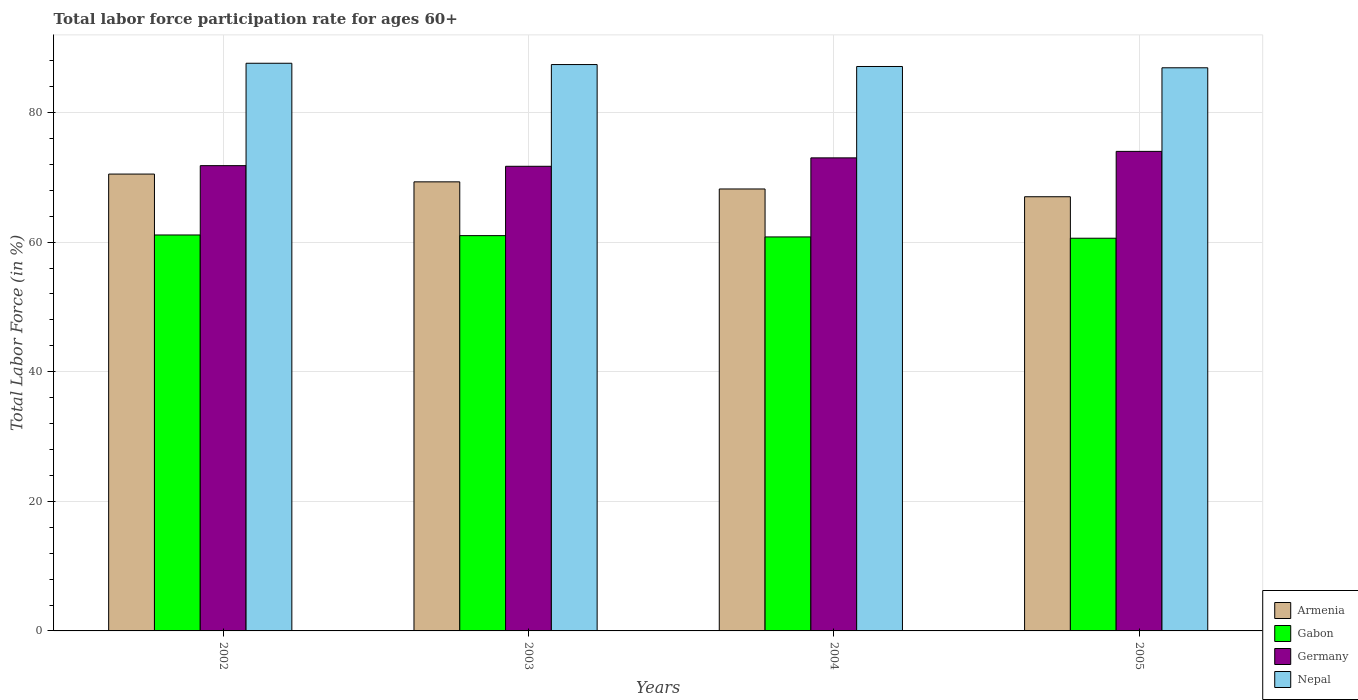Are the number of bars on each tick of the X-axis equal?
Keep it short and to the point. Yes. How many bars are there on the 1st tick from the left?
Keep it short and to the point. 4. How many bars are there on the 2nd tick from the right?
Keep it short and to the point. 4. What is the label of the 1st group of bars from the left?
Your answer should be very brief. 2002. In how many cases, is the number of bars for a given year not equal to the number of legend labels?
Ensure brevity in your answer.  0. What is the labor force participation rate in Gabon in 2004?
Offer a terse response. 60.8. Across all years, what is the maximum labor force participation rate in Gabon?
Your answer should be compact. 61.1. Across all years, what is the minimum labor force participation rate in Armenia?
Your answer should be compact. 67. In which year was the labor force participation rate in Germany maximum?
Give a very brief answer. 2005. What is the total labor force participation rate in Gabon in the graph?
Keep it short and to the point. 243.5. What is the difference between the labor force participation rate in Germany in 2003 and that in 2004?
Keep it short and to the point. -1.3. What is the difference between the labor force participation rate in Germany in 2002 and the labor force participation rate in Gabon in 2004?
Offer a very short reply. 11. What is the average labor force participation rate in Nepal per year?
Provide a short and direct response. 87.25. In the year 2002, what is the difference between the labor force participation rate in Gabon and labor force participation rate in Germany?
Offer a very short reply. -10.7. In how many years, is the labor force participation rate in Armenia greater than 80 %?
Offer a very short reply. 0. What is the ratio of the labor force participation rate in Gabon in 2004 to that in 2005?
Offer a terse response. 1. Is the labor force participation rate in Gabon in 2004 less than that in 2005?
Provide a short and direct response. No. What is the difference between the highest and the second highest labor force participation rate in Gabon?
Make the answer very short. 0.1. What is the difference between the highest and the lowest labor force participation rate in Germany?
Make the answer very short. 2.3. In how many years, is the labor force participation rate in Germany greater than the average labor force participation rate in Germany taken over all years?
Offer a terse response. 2. What does the 1st bar from the left in 2005 represents?
Offer a very short reply. Armenia. Is it the case that in every year, the sum of the labor force participation rate in Germany and labor force participation rate in Nepal is greater than the labor force participation rate in Armenia?
Your answer should be very brief. Yes. Are all the bars in the graph horizontal?
Keep it short and to the point. No. What is the difference between two consecutive major ticks on the Y-axis?
Give a very brief answer. 20. Are the values on the major ticks of Y-axis written in scientific E-notation?
Keep it short and to the point. No. Does the graph contain grids?
Keep it short and to the point. Yes. How many legend labels are there?
Provide a succinct answer. 4. What is the title of the graph?
Your answer should be very brief. Total labor force participation rate for ages 60+. What is the label or title of the X-axis?
Provide a short and direct response. Years. What is the Total Labor Force (in %) of Armenia in 2002?
Your answer should be compact. 70.5. What is the Total Labor Force (in %) of Gabon in 2002?
Your response must be concise. 61.1. What is the Total Labor Force (in %) in Germany in 2002?
Give a very brief answer. 71.8. What is the Total Labor Force (in %) in Nepal in 2002?
Provide a succinct answer. 87.6. What is the Total Labor Force (in %) in Armenia in 2003?
Give a very brief answer. 69.3. What is the Total Labor Force (in %) in Gabon in 2003?
Provide a succinct answer. 61. What is the Total Labor Force (in %) in Germany in 2003?
Make the answer very short. 71.7. What is the Total Labor Force (in %) of Nepal in 2003?
Provide a short and direct response. 87.4. What is the Total Labor Force (in %) in Armenia in 2004?
Provide a short and direct response. 68.2. What is the Total Labor Force (in %) of Gabon in 2004?
Your answer should be compact. 60.8. What is the Total Labor Force (in %) in Nepal in 2004?
Make the answer very short. 87.1. What is the Total Labor Force (in %) in Armenia in 2005?
Offer a very short reply. 67. What is the Total Labor Force (in %) of Gabon in 2005?
Keep it short and to the point. 60.6. What is the Total Labor Force (in %) of Nepal in 2005?
Your answer should be compact. 86.9. Across all years, what is the maximum Total Labor Force (in %) in Armenia?
Offer a very short reply. 70.5. Across all years, what is the maximum Total Labor Force (in %) of Gabon?
Make the answer very short. 61.1. Across all years, what is the maximum Total Labor Force (in %) in Germany?
Make the answer very short. 74. Across all years, what is the maximum Total Labor Force (in %) in Nepal?
Provide a succinct answer. 87.6. Across all years, what is the minimum Total Labor Force (in %) of Gabon?
Give a very brief answer. 60.6. Across all years, what is the minimum Total Labor Force (in %) of Germany?
Make the answer very short. 71.7. Across all years, what is the minimum Total Labor Force (in %) of Nepal?
Provide a succinct answer. 86.9. What is the total Total Labor Force (in %) in Armenia in the graph?
Provide a succinct answer. 275. What is the total Total Labor Force (in %) of Gabon in the graph?
Ensure brevity in your answer.  243.5. What is the total Total Labor Force (in %) of Germany in the graph?
Provide a short and direct response. 290.5. What is the total Total Labor Force (in %) in Nepal in the graph?
Provide a succinct answer. 349. What is the difference between the Total Labor Force (in %) of Gabon in 2002 and that in 2003?
Make the answer very short. 0.1. What is the difference between the Total Labor Force (in %) in Germany in 2002 and that in 2003?
Give a very brief answer. 0.1. What is the difference between the Total Labor Force (in %) of Nepal in 2002 and that in 2003?
Provide a short and direct response. 0.2. What is the difference between the Total Labor Force (in %) of Armenia in 2002 and that in 2004?
Provide a short and direct response. 2.3. What is the difference between the Total Labor Force (in %) of Gabon in 2002 and that in 2004?
Keep it short and to the point. 0.3. What is the difference between the Total Labor Force (in %) in Germany in 2002 and that in 2004?
Make the answer very short. -1.2. What is the difference between the Total Labor Force (in %) in Nepal in 2002 and that in 2004?
Your response must be concise. 0.5. What is the difference between the Total Labor Force (in %) of Armenia in 2002 and that in 2005?
Make the answer very short. 3.5. What is the difference between the Total Labor Force (in %) in Gabon in 2002 and that in 2005?
Provide a succinct answer. 0.5. What is the difference between the Total Labor Force (in %) of Germany in 2002 and that in 2005?
Make the answer very short. -2.2. What is the difference between the Total Labor Force (in %) of Nepal in 2002 and that in 2005?
Provide a succinct answer. 0.7. What is the difference between the Total Labor Force (in %) of Armenia in 2003 and that in 2004?
Make the answer very short. 1.1. What is the difference between the Total Labor Force (in %) of Germany in 2003 and that in 2004?
Your response must be concise. -1.3. What is the difference between the Total Labor Force (in %) in Gabon in 2003 and that in 2005?
Provide a succinct answer. 0.4. What is the difference between the Total Labor Force (in %) of Germany in 2003 and that in 2005?
Your response must be concise. -2.3. What is the difference between the Total Labor Force (in %) in Nepal in 2003 and that in 2005?
Ensure brevity in your answer.  0.5. What is the difference between the Total Labor Force (in %) in Nepal in 2004 and that in 2005?
Provide a succinct answer. 0.2. What is the difference between the Total Labor Force (in %) in Armenia in 2002 and the Total Labor Force (in %) in Nepal in 2003?
Your answer should be compact. -16.9. What is the difference between the Total Labor Force (in %) in Gabon in 2002 and the Total Labor Force (in %) in Germany in 2003?
Offer a terse response. -10.6. What is the difference between the Total Labor Force (in %) in Gabon in 2002 and the Total Labor Force (in %) in Nepal in 2003?
Provide a succinct answer. -26.3. What is the difference between the Total Labor Force (in %) in Germany in 2002 and the Total Labor Force (in %) in Nepal in 2003?
Ensure brevity in your answer.  -15.6. What is the difference between the Total Labor Force (in %) in Armenia in 2002 and the Total Labor Force (in %) in Germany in 2004?
Keep it short and to the point. -2.5. What is the difference between the Total Labor Force (in %) in Armenia in 2002 and the Total Labor Force (in %) in Nepal in 2004?
Make the answer very short. -16.6. What is the difference between the Total Labor Force (in %) of Germany in 2002 and the Total Labor Force (in %) of Nepal in 2004?
Give a very brief answer. -15.3. What is the difference between the Total Labor Force (in %) of Armenia in 2002 and the Total Labor Force (in %) of Gabon in 2005?
Keep it short and to the point. 9.9. What is the difference between the Total Labor Force (in %) of Armenia in 2002 and the Total Labor Force (in %) of Nepal in 2005?
Your answer should be compact. -16.4. What is the difference between the Total Labor Force (in %) of Gabon in 2002 and the Total Labor Force (in %) of Nepal in 2005?
Provide a succinct answer. -25.8. What is the difference between the Total Labor Force (in %) of Germany in 2002 and the Total Labor Force (in %) of Nepal in 2005?
Keep it short and to the point. -15.1. What is the difference between the Total Labor Force (in %) of Armenia in 2003 and the Total Labor Force (in %) of Germany in 2004?
Make the answer very short. -3.7. What is the difference between the Total Labor Force (in %) in Armenia in 2003 and the Total Labor Force (in %) in Nepal in 2004?
Your answer should be very brief. -17.8. What is the difference between the Total Labor Force (in %) of Gabon in 2003 and the Total Labor Force (in %) of Germany in 2004?
Make the answer very short. -12. What is the difference between the Total Labor Force (in %) in Gabon in 2003 and the Total Labor Force (in %) in Nepal in 2004?
Offer a very short reply. -26.1. What is the difference between the Total Labor Force (in %) of Germany in 2003 and the Total Labor Force (in %) of Nepal in 2004?
Your answer should be compact. -15.4. What is the difference between the Total Labor Force (in %) of Armenia in 2003 and the Total Labor Force (in %) of Nepal in 2005?
Keep it short and to the point. -17.6. What is the difference between the Total Labor Force (in %) in Gabon in 2003 and the Total Labor Force (in %) in Nepal in 2005?
Make the answer very short. -25.9. What is the difference between the Total Labor Force (in %) of Germany in 2003 and the Total Labor Force (in %) of Nepal in 2005?
Your answer should be compact. -15.2. What is the difference between the Total Labor Force (in %) of Armenia in 2004 and the Total Labor Force (in %) of Germany in 2005?
Ensure brevity in your answer.  -5.8. What is the difference between the Total Labor Force (in %) of Armenia in 2004 and the Total Labor Force (in %) of Nepal in 2005?
Your answer should be compact. -18.7. What is the difference between the Total Labor Force (in %) of Gabon in 2004 and the Total Labor Force (in %) of Nepal in 2005?
Offer a very short reply. -26.1. What is the difference between the Total Labor Force (in %) in Germany in 2004 and the Total Labor Force (in %) in Nepal in 2005?
Give a very brief answer. -13.9. What is the average Total Labor Force (in %) in Armenia per year?
Provide a succinct answer. 68.75. What is the average Total Labor Force (in %) of Gabon per year?
Your answer should be compact. 60.88. What is the average Total Labor Force (in %) of Germany per year?
Provide a succinct answer. 72.62. What is the average Total Labor Force (in %) of Nepal per year?
Offer a terse response. 87.25. In the year 2002, what is the difference between the Total Labor Force (in %) of Armenia and Total Labor Force (in %) of Nepal?
Provide a succinct answer. -17.1. In the year 2002, what is the difference between the Total Labor Force (in %) in Gabon and Total Labor Force (in %) in Nepal?
Your response must be concise. -26.5. In the year 2002, what is the difference between the Total Labor Force (in %) of Germany and Total Labor Force (in %) of Nepal?
Provide a succinct answer. -15.8. In the year 2003, what is the difference between the Total Labor Force (in %) of Armenia and Total Labor Force (in %) of Gabon?
Give a very brief answer. 8.3. In the year 2003, what is the difference between the Total Labor Force (in %) of Armenia and Total Labor Force (in %) of Nepal?
Provide a short and direct response. -18.1. In the year 2003, what is the difference between the Total Labor Force (in %) in Gabon and Total Labor Force (in %) in Germany?
Your answer should be very brief. -10.7. In the year 2003, what is the difference between the Total Labor Force (in %) in Gabon and Total Labor Force (in %) in Nepal?
Your response must be concise. -26.4. In the year 2003, what is the difference between the Total Labor Force (in %) of Germany and Total Labor Force (in %) of Nepal?
Provide a short and direct response. -15.7. In the year 2004, what is the difference between the Total Labor Force (in %) in Armenia and Total Labor Force (in %) in Nepal?
Your response must be concise. -18.9. In the year 2004, what is the difference between the Total Labor Force (in %) of Gabon and Total Labor Force (in %) of Germany?
Provide a succinct answer. -12.2. In the year 2004, what is the difference between the Total Labor Force (in %) of Gabon and Total Labor Force (in %) of Nepal?
Give a very brief answer. -26.3. In the year 2004, what is the difference between the Total Labor Force (in %) of Germany and Total Labor Force (in %) of Nepal?
Your answer should be compact. -14.1. In the year 2005, what is the difference between the Total Labor Force (in %) of Armenia and Total Labor Force (in %) of Nepal?
Your response must be concise. -19.9. In the year 2005, what is the difference between the Total Labor Force (in %) in Gabon and Total Labor Force (in %) in Germany?
Provide a short and direct response. -13.4. In the year 2005, what is the difference between the Total Labor Force (in %) of Gabon and Total Labor Force (in %) of Nepal?
Give a very brief answer. -26.3. In the year 2005, what is the difference between the Total Labor Force (in %) in Germany and Total Labor Force (in %) in Nepal?
Your response must be concise. -12.9. What is the ratio of the Total Labor Force (in %) in Armenia in 2002 to that in 2003?
Provide a short and direct response. 1.02. What is the ratio of the Total Labor Force (in %) in Armenia in 2002 to that in 2004?
Offer a terse response. 1.03. What is the ratio of the Total Labor Force (in %) in Gabon in 2002 to that in 2004?
Keep it short and to the point. 1. What is the ratio of the Total Labor Force (in %) of Germany in 2002 to that in 2004?
Offer a terse response. 0.98. What is the ratio of the Total Labor Force (in %) of Armenia in 2002 to that in 2005?
Your answer should be compact. 1.05. What is the ratio of the Total Labor Force (in %) in Gabon in 2002 to that in 2005?
Offer a very short reply. 1.01. What is the ratio of the Total Labor Force (in %) in Germany in 2002 to that in 2005?
Give a very brief answer. 0.97. What is the ratio of the Total Labor Force (in %) of Nepal in 2002 to that in 2005?
Ensure brevity in your answer.  1.01. What is the ratio of the Total Labor Force (in %) in Armenia in 2003 to that in 2004?
Your answer should be very brief. 1.02. What is the ratio of the Total Labor Force (in %) in Germany in 2003 to that in 2004?
Provide a short and direct response. 0.98. What is the ratio of the Total Labor Force (in %) in Nepal in 2003 to that in 2004?
Provide a succinct answer. 1. What is the ratio of the Total Labor Force (in %) in Armenia in 2003 to that in 2005?
Provide a succinct answer. 1.03. What is the ratio of the Total Labor Force (in %) of Gabon in 2003 to that in 2005?
Make the answer very short. 1.01. What is the ratio of the Total Labor Force (in %) of Germany in 2003 to that in 2005?
Give a very brief answer. 0.97. What is the ratio of the Total Labor Force (in %) of Nepal in 2003 to that in 2005?
Offer a very short reply. 1.01. What is the ratio of the Total Labor Force (in %) of Armenia in 2004 to that in 2005?
Offer a very short reply. 1.02. What is the ratio of the Total Labor Force (in %) of Gabon in 2004 to that in 2005?
Keep it short and to the point. 1. What is the ratio of the Total Labor Force (in %) in Germany in 2004 to that in 2005?
Offer a very short reply. 0.99. What is the ratio of the Total Labor Force (in %) in Nepal in 2004 to that in 2005?
Keep it short and to the point. 1. What is the difference between the highest and the second highest Total Labor Force (in %) in Armenia?
Provide a succinct answer. 1.2. What is the difference between the highest and the second highest Total Labor Force (in %) of Germany?
Offer a very short reply. 1. What is the difference between the highest and the lowest Total Labor Force (in %) of Germany?
Your answer should be compact. 2.3. What is the difference between the highest and the lowest Total Labor Force (in %) in Nepal?
Make the answer very short. 0.7. 